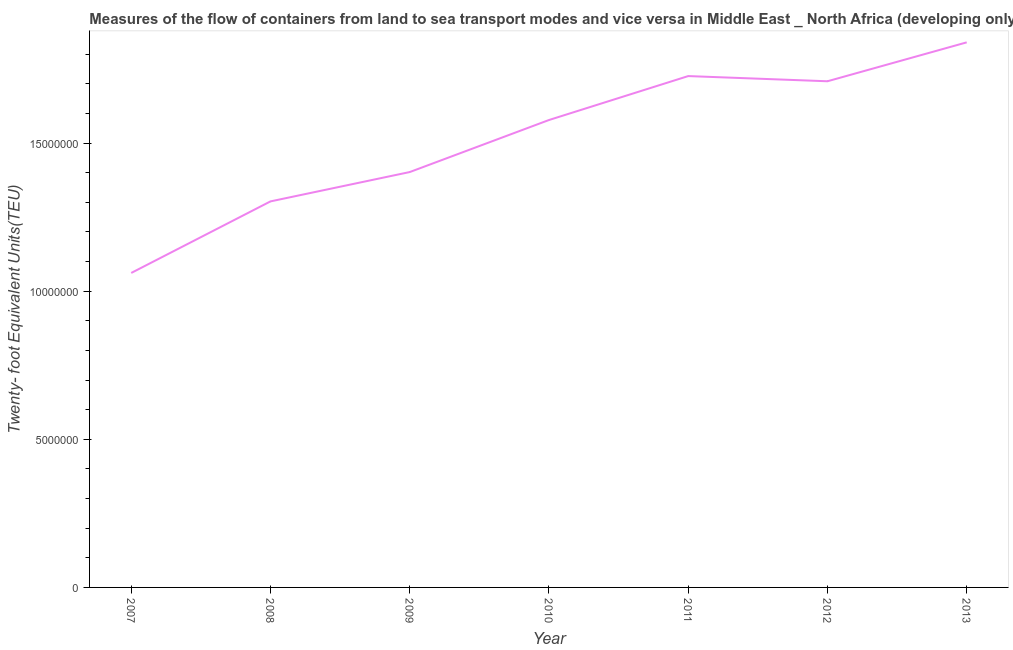What is the container port traffic in 2008?
Offer a terse response. 1.30e+07. Across all years, what is the maximum container port traffic?
Make the answer very short. 1.84e+07. Across all years, what is the minimum container port traffic?
Make the answer very short. 1.06e+07. In which year was the container port traffic maximum?
Your answer should be compact. 2013. In which year was the container port traffic minimum?
Give a very brief answer. 2007. What is the sum of the container port traffic?
Your answer should be very brief. 1.06e+08. What is the difference between the container port traffic in 2009 and 2012?
Your response must be concise. -3.06e+06. What is the average container port traffic per year?
Make the answer very short. 1.52e+07. What is the median container port traffic?
Offer a terse response. 1.58e+07. In how many years, is the container port traffic greater than 5000000 TEU?
Your response must be concise. 7. Do a majority of the years between 2013 and 2010 (inclusive) have container port traffic greater than 15000000 TEU?
Offer a very short reply. Yes. What is the ratio of the container port traffic in 2010 to that in 2011?
Give a very brief answer. 0.91. Is the difference between the container port traffic in 2008 and 2010 greater than the difference between any two years?
Provide a succinct answer. No. What is the difference between the highest and the second highest container port traffic?
Ensure brevity in your answer.  1.14e+06. What is the difference between the highest and the lowest container port traffic?
Give a very brief answer. 7.78e+06. Does the container port traffic monotonically increase over the years?
Give a very brief answer. No. How many lines are there?
Make the answer very short. 1. How many years are there in the graph?
Provide a short and direct response. 7. What is the difference between two consecutive major ticks on the Y-axis?
Ensure brevity in your answer.  5.00e+06. Are the values on the major ticks of Y-axis written in scientific E-notation?
Your response must be concise. No. What is the title of the graph?
Provide a succinct answer. Measures of the flow of containers from land to sea transport modes and vice versa in Middle East _ North Africa (developing only). What is the label or title of the X-axis?
Provide a short and direct response. Year. What is the label or title of the Y-axis?
Provide a short and direct response. Twenty- foot Equivalent Units(TEU). What is the Twenty- foot Equivalent Units(TEU) of 2007?
Give a very brief answer. 1.06e+07. What is the Twenty- foot Equivalent Units(TEU) of 2008?
Your answer should be very brief. 1.30e+07. What is the Twenty- foot Equivalent Units(TEU) in 2009?
Keep it short and to the point. 1.40e+07. What is the Twenty- foot Equivalent Units(TEU) in 2010?
Your response must be concise. 1.58e+07. What is the Twenty- foot Equivalent Units(TEU) in 2011?
Your answer should be compact. 1.73e+07. What is the Twenty- foot Equivalent Units(TEU) in 2012?
Give a very brief answer. 1.71e+07. What is the Twenty- foot Equivalent Units(TEU) in 2013?
Your response must be concise. 1.84e+07. What is the difference between the Twenty- foot Equivalent Units(TEU) in 2007 and 2008?
Offer a terse response. -2.42e+06. What is the difference between the Twenty- foot Equivalent Units(TEU) in 2007 and 2009?
Offer a terse response. -3.41e+06. What is the difference between the Twenty- foot Equivalent Units(TEU) in 2007 and 2010?
Provide a succinct answer. -5.16e+06. What is the difference between the Twenty- foot Equivalent Units(TEU) in 2007 and 2011?
Provide a short and direct response. -6.65e+06. What is the difference between the Twenty- foot Equivalent Units(TEU) in 2007 and 2012?
Offer a very short reply. -6.47e+06. What is the difference between the Twenty- foot Equivalent Units(TEU) in 2007 and 2013?
Give a very brief answer. -7.78e+06. What is the difference between the Twenty- foot Equivalent Units(TEU) in 2008 and 2009?
Keep it short and to the point. -9.90e+05. What is the difference between the Twenty- foot Equivalent Units(TEU) in 2008 and 2010?
Keep it short and to the point. -2.75e+06. What is the difference between the Twenty- foot Equivalent Units(TEU) in 2008 and 2011?
Your answer should be compact. -4.23e+06. What is the difference between the Twenty- foot Equivalent Units(TEU) in 2008 and 2012?
Offer a terse response. -4.06e+06. What is the difference between the Twenty- foot Equivalent Units(TEU) in 2008 and 2013?
Offer a very short reply. -5.37e+06. What is the difference between the Twenty- foot Equivalent Units(TEU) in 2009 and 2010?
Offer a very short reply. -1.76e+06. What is the difference between the Twenty- foot Equivalent Units(TEU) in 2009 and 2011?
Keep it short and to the point. -3.24e+06. What is the difference between the Twenty- foot Equivalent Units(TEU) in 2009 and 2012?
Ensure brevity in your answer.  -3.06e+06. What is the difference between the Twenty- foot Equivalent Units(TEU) in 2009 and 2013?
Ensure brevity in your answer.  -4.38e+06. What is the difference between the Twenty- foot Equivalent Units(TEU) in 2010 and 2011?
Your response must be concise. -1.48e+06. What is the difference between the Twenty- foot Equivalent Units(TEU) in 2010 and 2012?
Keep it short and to the point. -1.31e+06. What is the difference between the Twenty- foot Equivalent Units(TEU) in 2010 and 2013?
Provide a short and direct response. -2.62e+06. What is the difference between the Twenty- foot Equivalent Units(TEU) in 2011 and 2012?
Make the answer very short. 1.75e+05. What is the difference between the Twenty- foot Equivalent Units(TEU) in 2011 and 2013?
Provide a succinct answer. -1.14e+06. What is the difference between the Twenty- foot Equivalent Units(TEU) in 2012 and 2013?
Make the answer very short. -1.31e+06. What is the ratio of the Twenty- foot Equivalent Units(TEU) in 2007 to that in 2008?
Offer a very short reply. 0.81. What is the ratio of the Twenty- foot Equivalent Units(TEU) in 2007 to that in 2009?
Keep it short and to the point. 0.76. What is the ratio of the Twenty- foot Equivalent Units(TEU) in 2007 to that in 2010?
Provide a succinct answer. 0.67. What is the ratio of the Twenty- foot Equivalent Units(TEU) in 2007 to that in 2011?
Ensure brevity in your answer.  0.61. What is the ratio of the Twenty- foot Equivalent Units(TEU) in 2007 to that in 2012?
Your answer should be compact. 0.62. What is the ratio of the Twenty- foot Equivalent Units(TEU) in 2007 to that in 2013?
Provide a succinct answer. 0.58. What is the ratio of the Twenty- foot Equivalent Units(TEU) in 2008 to that in 2009?
Keep it short and to the point. 0.93. What is the ratio of the Twenty- foot Equivalent Units(TEU) in 2008 to that in 2010?
Ensure brevity in your answer.  0.83. What is the ratio of the Twenty- foot Equivalent Units(TEU) in 2008 to that in 2011?
Your response must be concise. 0.76. What is the ratio of the Twenty- foot Equivalent Units(TEU) in 2008 to that in 2012?
Give a very brief answer. 0.76. What is the ratio of the Twenty- foot Equivalent Units(TEU) in 2008 to that in 2013?
Your answer should be compact. 0.71. What is the ratio of the Twenty- foot Equivalent Units(TEU) in 2009 to that in 2010?
Ensure brevity in your answer.  0.89. What is the ratio of the Twenty- foot Equivalent Units(TEU) in 2009 to that in 2011?
Your answer should be compact. 0.81. What is the ratio of the Twenty- foot Equivalent Units(TEU) in 2009 to that in 2012?
Offer a terse response. 0.82. What is the ratio of the Twenty- foot Equivalent Units(TEU) in 2009 to that in 2013?
Provide a short and direct response. 0.76. What is the ratio of the Twenty- foot Equivalent Units(TEU) in 2010 to that in 2011?
Keep it short and to the point. 0.91. What is the ratio of the Twenty- foot Equivalent Units(TEU) in 2010 to that in 2012?
Give a very brief answer. 0.92. What is the ratio of the Twenty- foot Equivalent Units(TEU) in 2010 to that in 2013?
Your answer should be very brief. 0.86. What is the ratio of the Twenty- foot Equivalent Units(TEU) in 2011 to that in 2012?
Your answer should be compact. 1.01. What is the ratio of the Twenty- foot Equivalent Units(TEU) in 2011 to that in 2013?
Make the answer very short. 0.94. What is the ratio of the Twenty- foot Equivalent Units(TEU) in 2012 to that in 2013?
Your response must be concise. 0.93. 